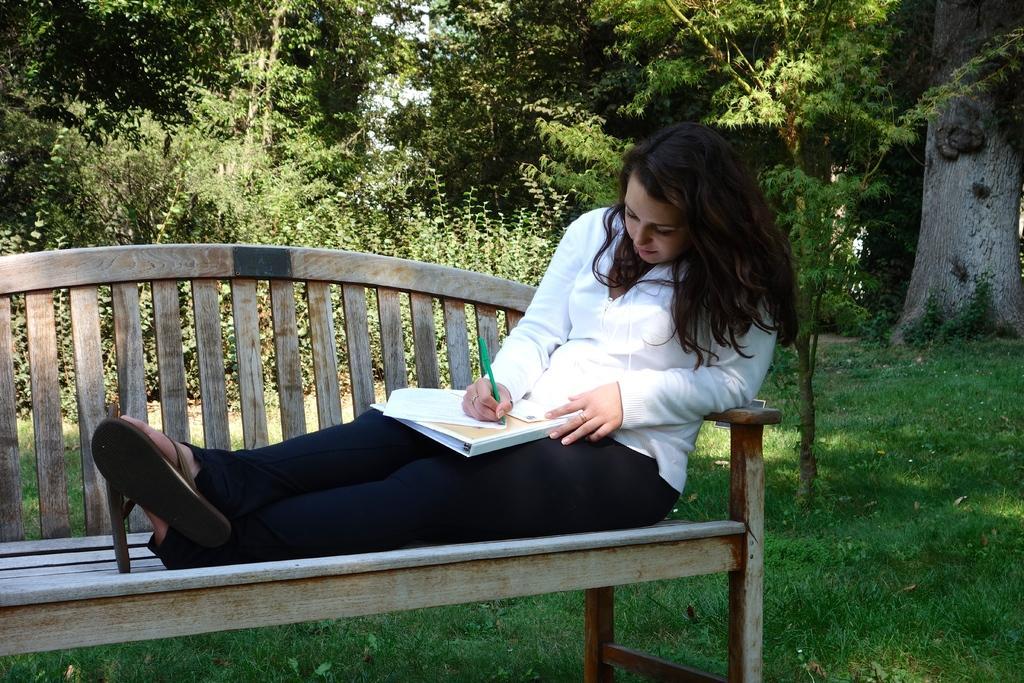How would you summarize this image in a sentence or two? This picture shows a woman sitting on the bench in the park, writing something on a paper. In the background there are some trees and plants here. 